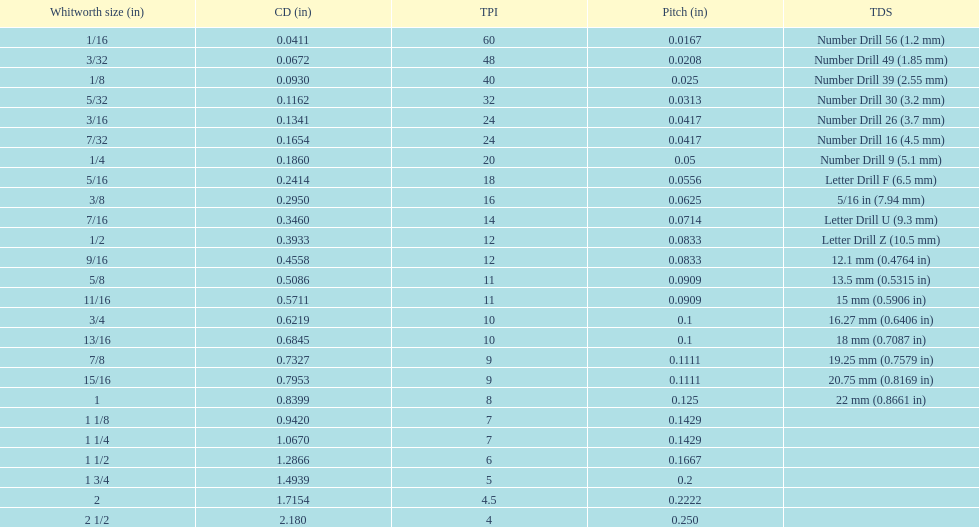I'm looking to parse the entire table for insights. Could you assist me with that? {'header': ['Whitworth size (in)', 'CD (in)', 'TPI', 'Pitch (in)', 'TDS'], 'rows': [['1/16', '0.0411', '60', '0.0167', 'Number Drill 56 (1.2\xa0mm)'], ['3/32', '0.0672', '48', '0.0208', 'Number Drill 49 (1.85\xa0mm)'], ['1/8', '0.0930', '40', '0.025', 'Number Drill 39 (2.55\xa0mm)'], ['5/32', '0.1162', '32', '0.0313', 'Number Drill 30 (3.2\xa0mm)'], ['3/16', '0.1341', '24', '0.0417', 'Number Drill 26 (3.7\xa0mm)'], ['7/32', '0.1654', '24', '0.0417', 'Number Drill 16 (4.5\xa0mm)'], ['1/4', '0.1860', '20', '0.05', 'Number Drill 9 (5.1\xa0mm)'], ['5/16', '0.2414', '18', '0.0556', 'Letter Drill F (6.5\xa0mm)'], ['3/8', '0.2950', '16', '0.0625', '5/16\xa0in (7.94\xa0mm)'], ['7/16', '0.3460', '14', '0.0714', 'Letter Drill U (9.3\xa0mm)'], ['1/2', '0.3933', '12', '0.0833', 'Letter Drill Z (10.5\xa0mm)'], ['9/16', '0.4558', '12', '0.0833', '12.1\xa0mm (0.4764\xa0in)'], ['5/8', '0.5086', '11', '0.0909', '13.5\xa0mm (0.5315\xa0in)'], ['11/16', '0.5711', '11', '0.0909', '15\xa0mm (0.5906\xa0in)'], ['3/4', '0.6219', '10', '0.1', '16.27\xa0mm (0.6406\xa0in)'], ['13/16', '0.6845', '10', '0.1', '18\xa0mm (0.7087\xa0in)'], ['7/8', '0.7327', '9', '0.1111', '19.25\xa0mm (0.7579\xa0in)'], ['15/16', '0.7953', '9', '0.1111', '20.75\xa0mm (0.8169\xa0in)'], ['1', '0.8399', '8', '0.125', '22\xa0mm (0.8661\xa0in)'], ['1 1/8', '0.9420', '7', '0.1429', ''], ['1 1/4', '1.0670', '7', '0.1429', ''], ['1 1/2', '1.2866', '6', '0.1667', ''], ['1 3/4', '1.4939', '5', '0.2', ''], ['2', '1.7154', '4.5', '0.2222', ''], ['2 1/2', '2.180', '4', '0.250', '']]} What is the top amount of threads per inch? 60. 